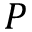<formula> <loc_0><loc_0><loc_500><loc_500>P</formula> 